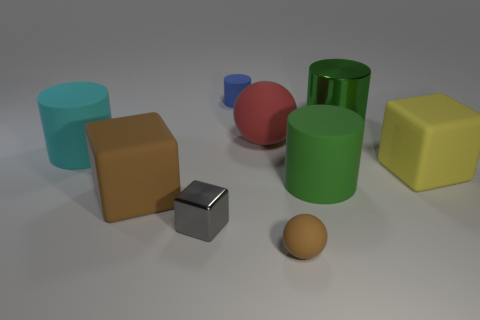How many large cubes have the same color as the tiny rubber sphere?
Provide a short and direct response. 1. Is the yellow object the same shape as the cyan rubber thing?
Offer a very short reply. No. What is the size of the cylinder that is in front of the big cyan cylinder?
Provide a succinct answer. Large. What size is the red ball that is made of the same material as the large yellow thing?
Offer a terse response. Large. Are there fewer small blue cylinders than small metallic cylinders?
Offer a very short reply. No. There is a sphere that is the same size as the cyan thing; what is it made of?
Make the answer very short. Rubber. Are there more small red metal things than tiny gray shiny objects?
Your answer should be very brief. No. How many other objects are the same color as the small rubber cylinder?
Make the answer very short. 0. How many things are both behind the large green matte cylinder and right of the brown sphere?
Ensure brevity in your answer.  2. Is there any other thing that is the same size as the shiny cylinder?
Provide a succinct answer. Yes. 